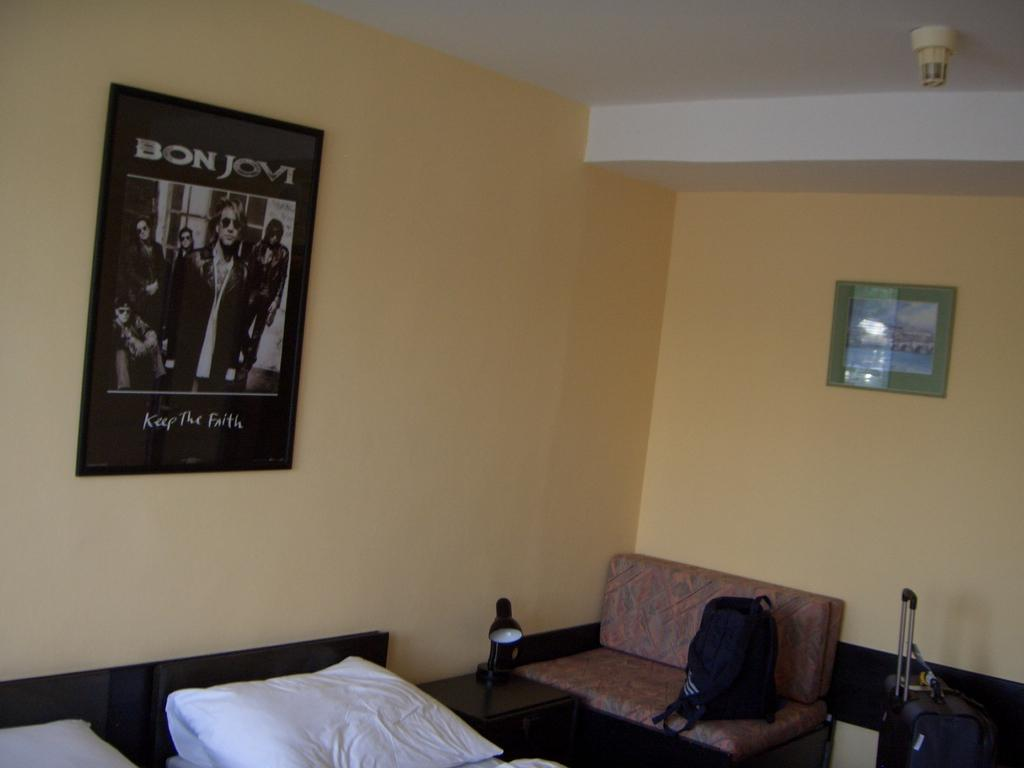What type of room is the image taken in? The image is taken in a bedroom. What is the main piece of furniture in the room? There is a bed in the room. What is placed on the bed? There are pillows on the bed. Are there any other furniture pieces in the room? Yes, there is a table and a couch in the room. What other items can be seen in the room? There is a bag, a trolley, and frames attached to the wall in the room. What direction is the railway heading in the image? There is no railway present in the image. How does the drain function in the room? There is no drain present in the room. 